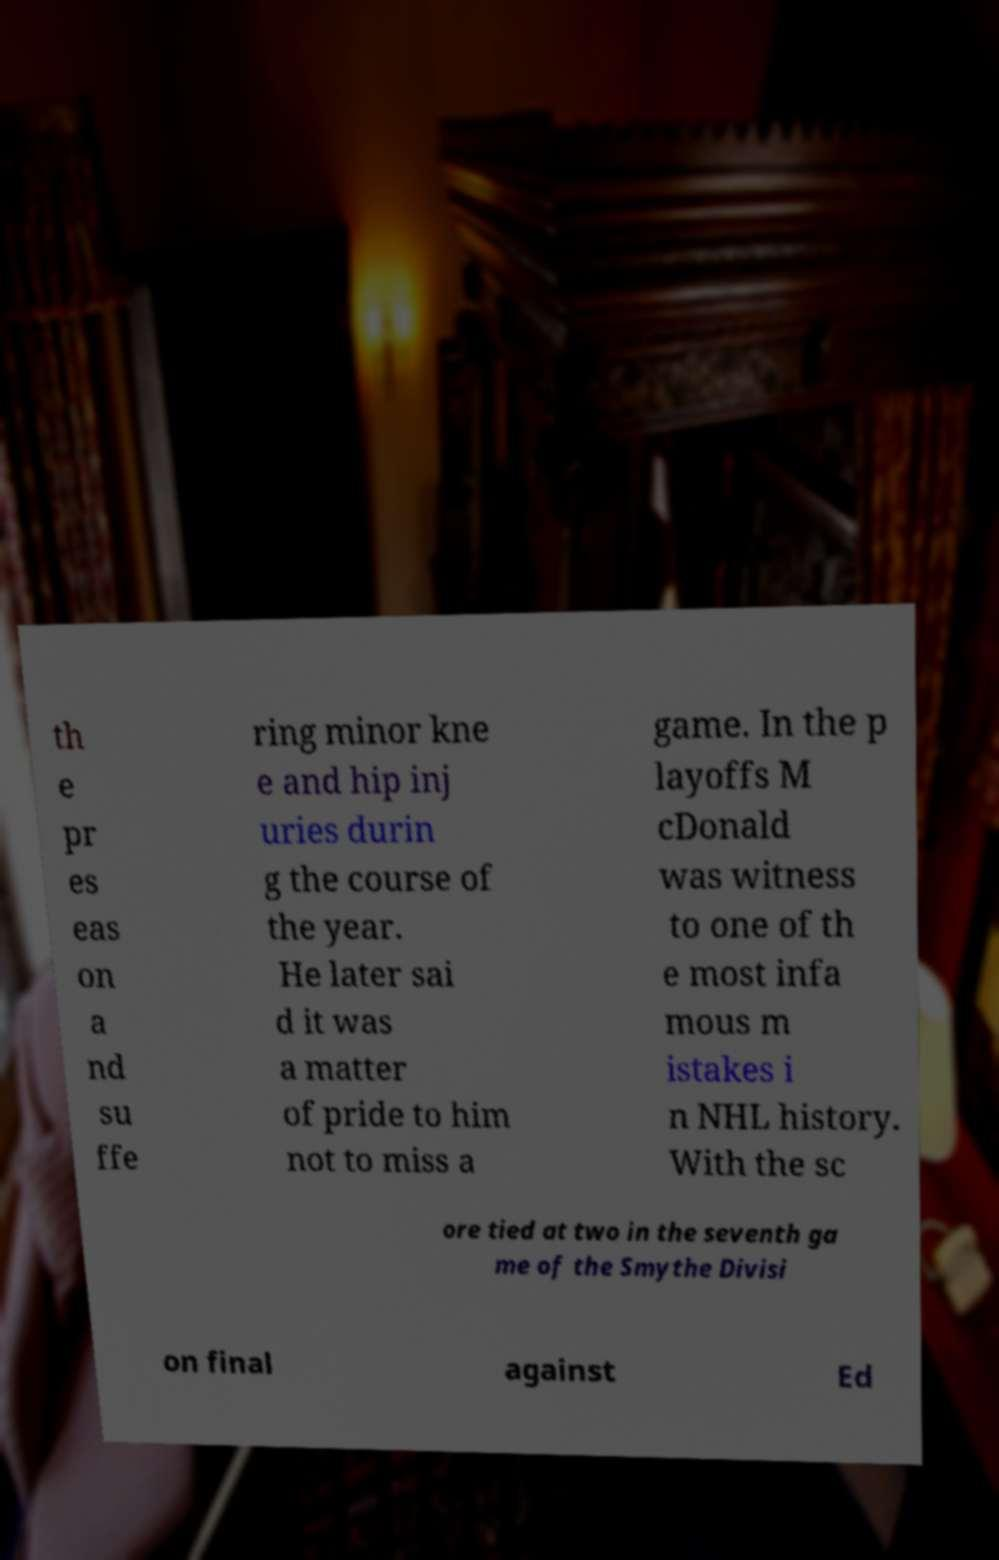Can you accurately transcribe the text from the provided image for me? th e pr es eas on a nd su ffe ring minor kne e and hip inj uries durin g the course of the year. He later sai d it was a matter of pride to him not to miss a game. In the p layoffs M cDonald was witness to one of th e most infa mous m istakes i n NHL history. With the sc ore tied at two in the seventh ga me of the Smythe Divisi on final against Ed 